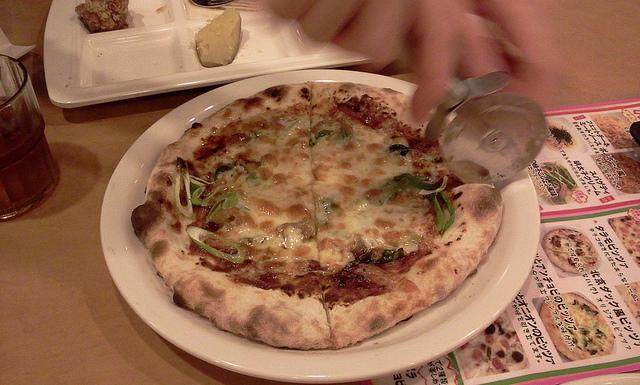In which style white pizza made of?

Choices:
A) german
B) italian
C) australian
D) arab italian 